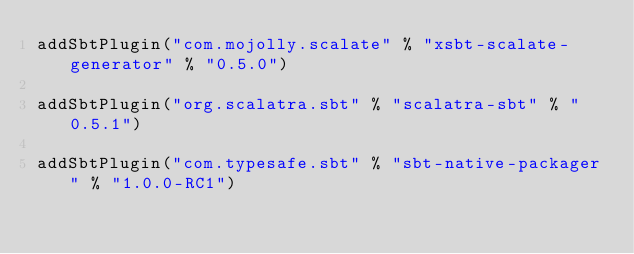Convert code to text. <code><loc_0><loc_0><loc_500><loc_500><_Scala_>addSbtPlugin("com.mojolly.scalate" % "xsbt-scalate-generator" % "0.5.0")

addSbtPlugin("org.scalatra.sbt" % "scalatra-sbt" % "0.5.1")

addSbtPlugin("com.typesafe.sbt" % "sbt-native-packager" % "1.0.0-RC1")</code> 